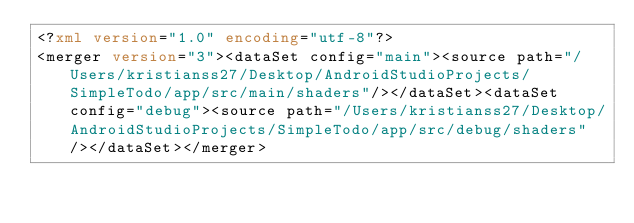Convert code to text. <code><loc_0><loc_0><loc_500><loc_500><_XML_><?xml version="1.0" encoding="utf-8"?>
<merger version="3"><dataSet config="main"><source path="/Users/kristianss27/Desktop/AndroidStudioProjects/SimpleTodo/app/src/main/shaders"/></dataSet><dataSet config="debug"><source path="/Users/kristianss27/Desktop/AndroidStudioProjects/SimpleTodo/app/src/debug/shaders"/></dataSet></merger></code> 